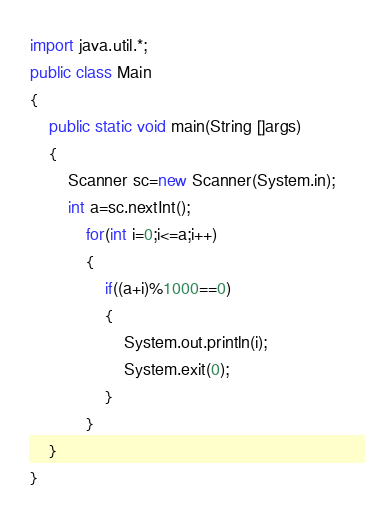Convert code to text. <code><loc_0><loc_0><loc_500><loc_500><_Java_>import java.util.*;
public class Main
{
    public static void main(String []args)
    {
        Scanner sc=new Scanner(System.in);
        int a=sc.nextInt();
            for(int i=0;i<=a;i++)
            {
                if((a+i)%1000==0)
                { 
                    System.out.println(i);
                    System.exit(0);
                }
            }
    }
}</code> 